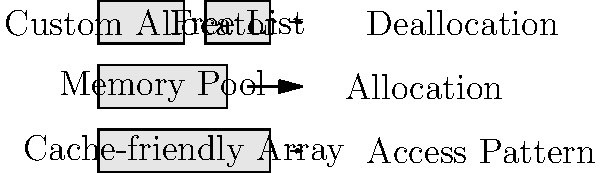In the memory allocation diagram for a large-scale financial simulation, which optimization strategy is most likely to improve cache performance and reduce memory fragmentation? To determine the best optimization strategy for improving cache performance and reducing memory fragmentation in large-scale financial simulations, let's analyze each component in the diagram:

1. Cache-friendly Array:
   - Improves cache performance by ensuring data is stored contiguously in memory.
   - Allows for efficient sequential access, which is crucial for many financial algorithms.
   - However, it doesn't directly address memory fragmentation.

2. Memory Pool:
   - Pre-allocates a large chunk of memory for future use.
   - Reduces allocation overhead and can help with fragmentation by managing memory in fixed-size blocks.
   - Doesn't inherently improve cache performance, though it can be designed to do so.

3. Custom Allocator:
   - Provides fine-grained control over memory allocation and deallocation.
   - Can be tailored to the specific needs of financial simulations.
   - Allows for implementing cache-friendly allocation strategies and reducing fragmentation.

4. Free List:
   - Manages deallocated memory blocks for quick reuse.
   - Helps reduce fragmentation by recycling memory.
   - Doesn't directly improve cache performance.

Among these options, the Custom Allocator provides the most comprehensive solution for both improving cache performance and reducing memory fragmentation:

1. It can implement cache-friendly allocation strategies, ensuring that frequently accessed data is stored in contiguous memory locations.
2. It can be designed to minimize fragmentation by intelligently managing memory blocks and implementing compaction techniques.
3. It can incorporate both Memory Pool and Free List concepts for efficient memory management.
4. It can be tailored to the specific access patterns and memory requirements of financial simulations.

Therefore, the Custom Allocator is the most likely strategy to achieve both improved cache performance and reduced memory fragmentation in large-scale financial simulations.
Answer: Custom Allocator 